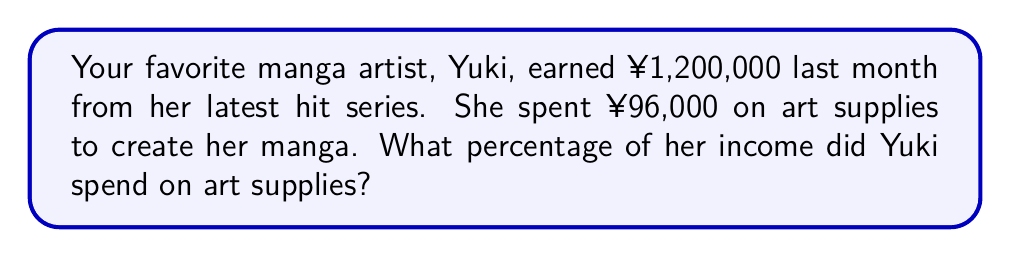Could you help me with this problem? Let's break this down step-by-step:

1. Identify the given information:
   - Yuki's income: ¥1,200,000
   - Amount spent on art supplies: ¥96,000

2. To find the percentage, we need to divide the amount spent on art supplies by the total income and then multiply by 100:

   $$ \text{Percentage} = \frac{\text{Amount spent on art supplies}}{\text{Total income}} \times 100 $$

3. Plug in the numbers:

   $$ \text{Percentage} = \frac{96,000}{1,200,000} \times 100 $$

4. Simplify the fraction:
   
   $$ \text{Percentage} = \frac{96,000}{1,200,000} \times 100 = \frac{4}{50} \times 100 $$

5. Multiply:
   
   $$ \text{Percentage} = 0.08 \times 100 = 8 $$

Therefore, Yuki spent 8% of her income on art supplies.
Answer: 8% 